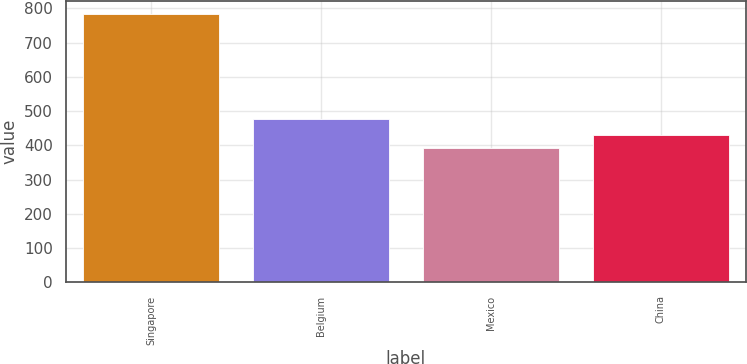<chart> <loc_0><loc_0><loc_500><loc_500><bar_chart><fcel>Singapore<fcel>Belgium<fcel>Mexico<fcel>China<nl><fcel>783<fcel>478<fcel>391<fcel>430.2<nl></chart> 